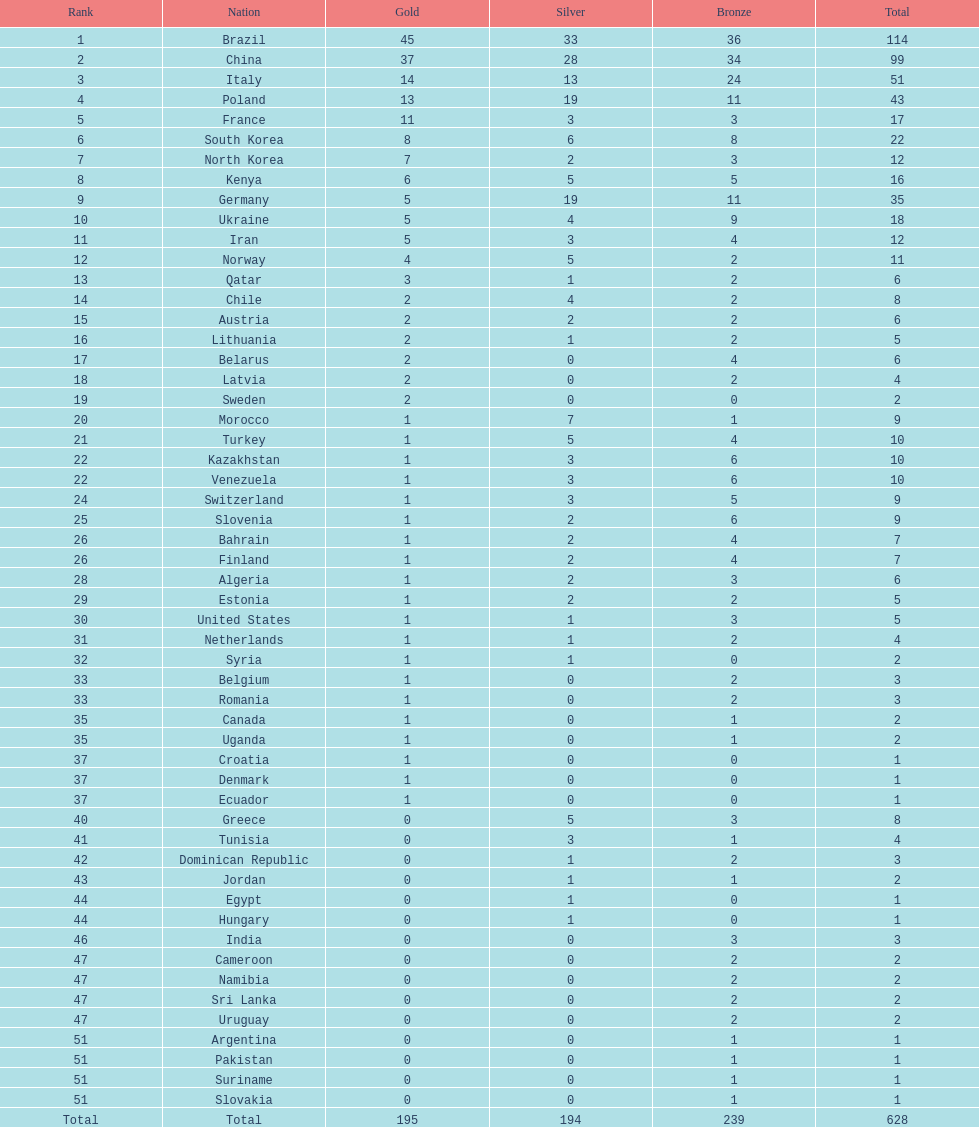I'm looking to parse the entire table for insights. Could you assist me with that? {'header': ['Rank', 'Nation', 'Gold', 'Silver', 'Bronze', 'Total'], 'rows': [['1', 'Brazil', '45', '33', '36', '114'], ['2', 'China', '37', '28', '34', '99'], ['3', 'Italy', '14', '13', '24', '51'], ['4', 'Poland', '13', '19', '11', '43'], ['5', 'France', '11', '3', '3', '17'], ['6', 'South Korea', '8', '6', '8', '22'], ['7', 'North Korea', '7', '2', '3', '12'], ['8', 'Kenya', '6', '5', '5', '16'], ['9', 'Germany', '5', '19', '11', '35'], ['10', 'Ukraine', '5', '4', '9', '18'], ['11', 'Iran', '5', '3', '4', '12'], ['12', 'Norway', '4', '5', '2', '11'], ['13', 'Qatar', '3', '1', '2', '6'], ['14', 'Chile', '2', '4', '2', '8'], ['15', 'Austria', '2', '2', '2', '6'], ['16', 'Lithuania', '2', '1', '2', '5'], ['17', 'Belarus', '2', '0', '4', '6'], ['18', 'Latvia', '2', '0', '2', '4'], ['19', 'Sweden', '2', '0', '0', '2'], ['20', 'Morocco', '1', '7', '1', '9'], ['21', 'Turkey', '1', '5', '4', '10'], ['22', 'Kazakhstan', '1', '3', '6', '10'], ['22', 'Venezuela', '1', '3', '6', '10'], ['24', 'Switzerland', '1', '3', '5', '9'], ['25', 'Slovenia', '1', '2', '6', '9'], ['26', 'Bahrain', '1', '2', '4', '7'], ['26', 'Finland', '1', '2', '4', '7'], ['28', 'Algeria', '1', '2', '3', '6'], ['29', 'Estonia', '1', '2', '2', '5'], ['30', 'United States', '1', '1', '3', '5'], ['31', 'Netherlands', '1', '1', '2', '4'], ['32', 'Syria', '1', '1', '0', '2'], ['33', 'Belgium', '1', '0', '2', '3'], ['33', 'Romania', '1', '0', '2', '3'], ['35', 'Canada', '1', '0', '1', '2'], ['35', 'Uganda', '1', '0', '1', '2'], ['37', 'Croatia', '1', '0', '0', '1'], ['37', 'Denmark', '1', '0', '0', '1'], ['37', 'Ecuador', '1', '0', '0', '1'], ['40', 'Greece', '0', '5', '3', '8'], ['41', 'Tunisia', '0', '3', '1', '4'], ['42', 'Dominican Republic', '0', '1', '2', '3'], ['43', 'Jordan', '0', '1', '1', '2'], ['44', 'Egypt', '0', '1', '0', '1'], ['44', 'Hungary', '0', '1', '0', '1'], ['46', 'India', '0', '0', '3', '3'], ['47', 'Cameroon', '0', '0', '2', '2'], ['47', 'Namibia', '0', '0', '2', '2'], ['47', 'Sri Lanka', '0', '0', '2', '2'], ['47', 'Uruguay', '0', '0', '2', '2'], ['51', 'Argentina', '0', '0', '1', '1'], ['51', 'Pakistan', '0', '0', '1', '1'], ['51', 'Suriname', '0', '0', '1', '1'], ['51', 'Slovakia', '0', '0', '1', '1'], ['Total', 'Total', '195', '194', '239', '628']]} Did italy or norway have 51 total medals? Italy. 